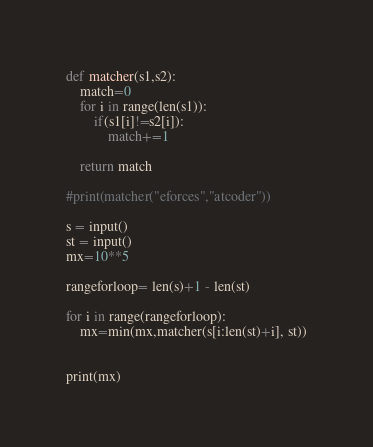<code> <loc_0><loc_0><loc_500><loc_500><_Python_>def matcher(s1,s2):
    match=0
    for i in range(len(s1)):
        if(s1[i]!=s2[i]):
            match+=1
            
    return match

#print(matcher("eforces","atcoder"))

s = input()
st = input()
mx=10**5

rangeforloop= len(s)+1 - len(st)
 
for i in range(rangeforloop):
    mx=min(mx,matcher(s[i:len(st)+i], st))
    
     
print(mx)</code> 